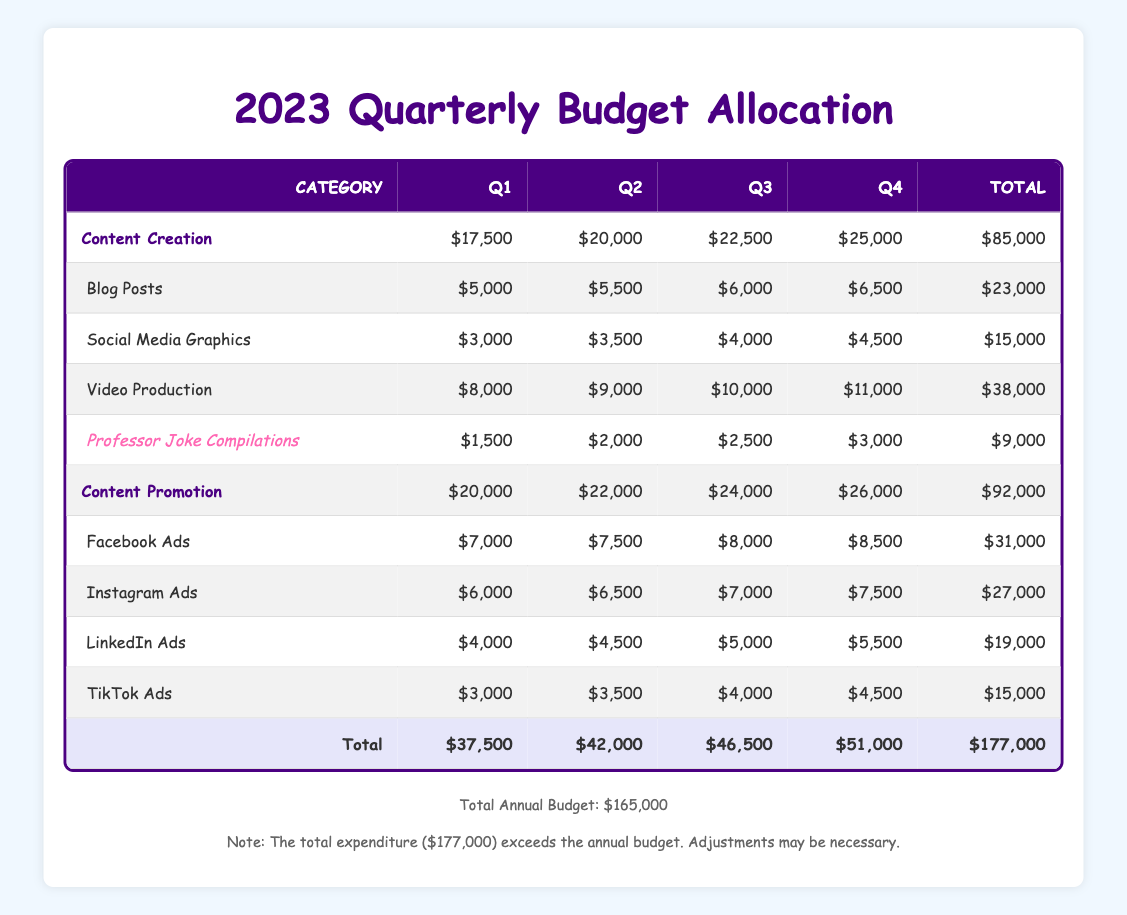What's the total budget for content creation in Q3? In Q3, the total budget for content creation is provided in the table. By summing the amounts allocated to each category under content creation for Q3: Blog Posts ($6,000) + Social Media Graphics ($4,000) + Video Production ($10,000) + Professor Joke Compilations ($2,500) = $22,500.
Answer: $22,500 How much is allocated for Facebook Ads in Q1? The table shows that for Q1, the amount allocated to Facebook Ads is $7,000 directly listed under the content promotion section.
Answer: $7,000 Is the total expenditure higher than the annual budget? The total expenditure shown in the table sums to $177,000 across all quarters, while the total annual budget is $165,000. Since $177,000 is greater than $165,000, the answer is yes.
Answer: Yes What was the increase in the allocation for video production from Q1 to Q4? The table indicates the video production budget for Q1 is $8,000 and for Q4 it is $11,000. The increase is calculated as $11,000 - $8,000 = $3,000.
Answer: $3,000 What is the average budget allocation for Instagram Ads across all quarters? The amounts for Instagram Ads across the four quarters are Q1 ($6,000), Q2 ($6,500), Q3 ($7,000), and Q4 ($7,500). To find the average, sum these amounts: $6,000 + $6,500 + $7,000 + $7,500 = $27,000 and then divide by 4: $27,000 / 4 = $6,750.
Answer: $6,750 Which quarter had the highest allocation for content promotion? The table presents the total allocations for content promotion per quarter as Q1 ($20,000), Q2 ($22,000), Q3 ($24,000), and Q4 ($26,000). Q4 has the highest value at $26,000.
Answer: Q4 What is the total amount allocated for professor joke compilations for the year? The specific allocations for professor joke compilations are $1,500 in Q1, $2,000 in Q2, $2,500 in Q3, and $3,000 in Q4. Summing these figures gives $1,500 + $2,000 + $2,500 + $3,000 = $9,000.
Answer: $9,000 Is there an increase in budget for social media graphics from Q2 to Q3? Under the content creation category, social media graphics allocations are $3,500 in Q2 and $4,000 in Q3. The difference is $4,000 - $3,500 = $500, indicating an increase.
Answer: Yes What is the total allocation for content creation for the entire year? The total allocations for content creation are $17,500 in Q1, $20,000 in Q2, $22,500 in Q3, and $25,000 in Q4. Adding these gives $17,500 + $20,000 + $22,500 + $25,000 = $85,000 total for the year.
Answer: $85,000 